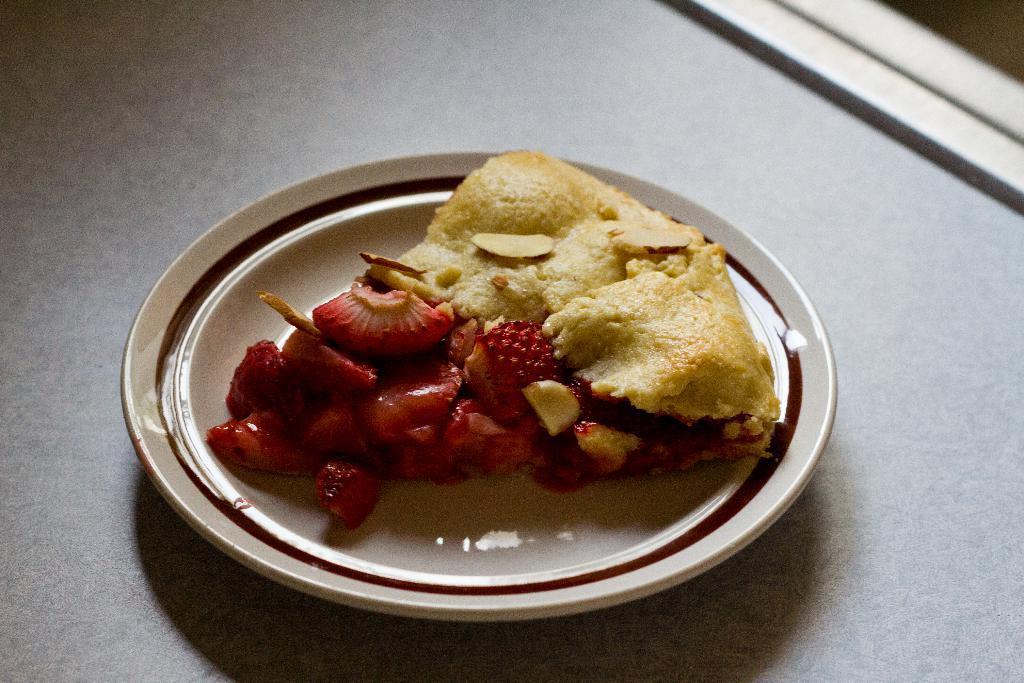Describe this image in one or two sentences. In this picture there is food on the plate. At the bottom there might be a table. 